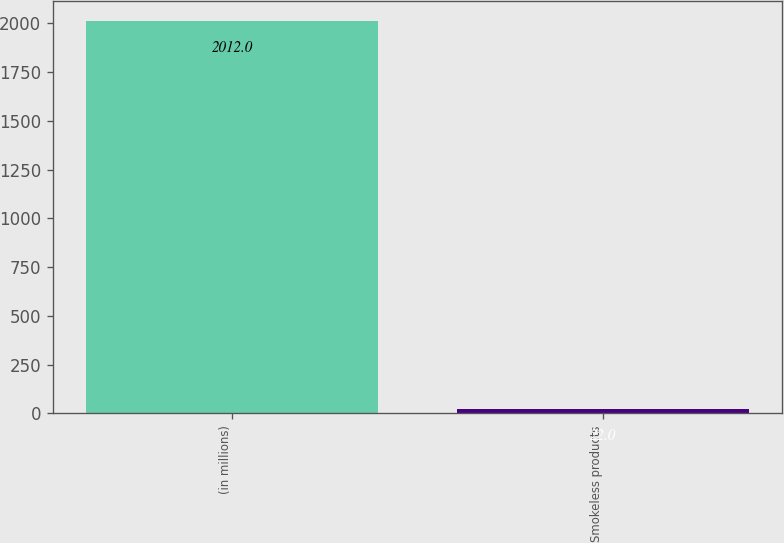<chart> <loc_0><loc_0><loc_500><loc_500><bar_chart><fcel>(in millions)<fcel>Smokeless products<nl><fcel>2012<fcel>22<nl></chart> 